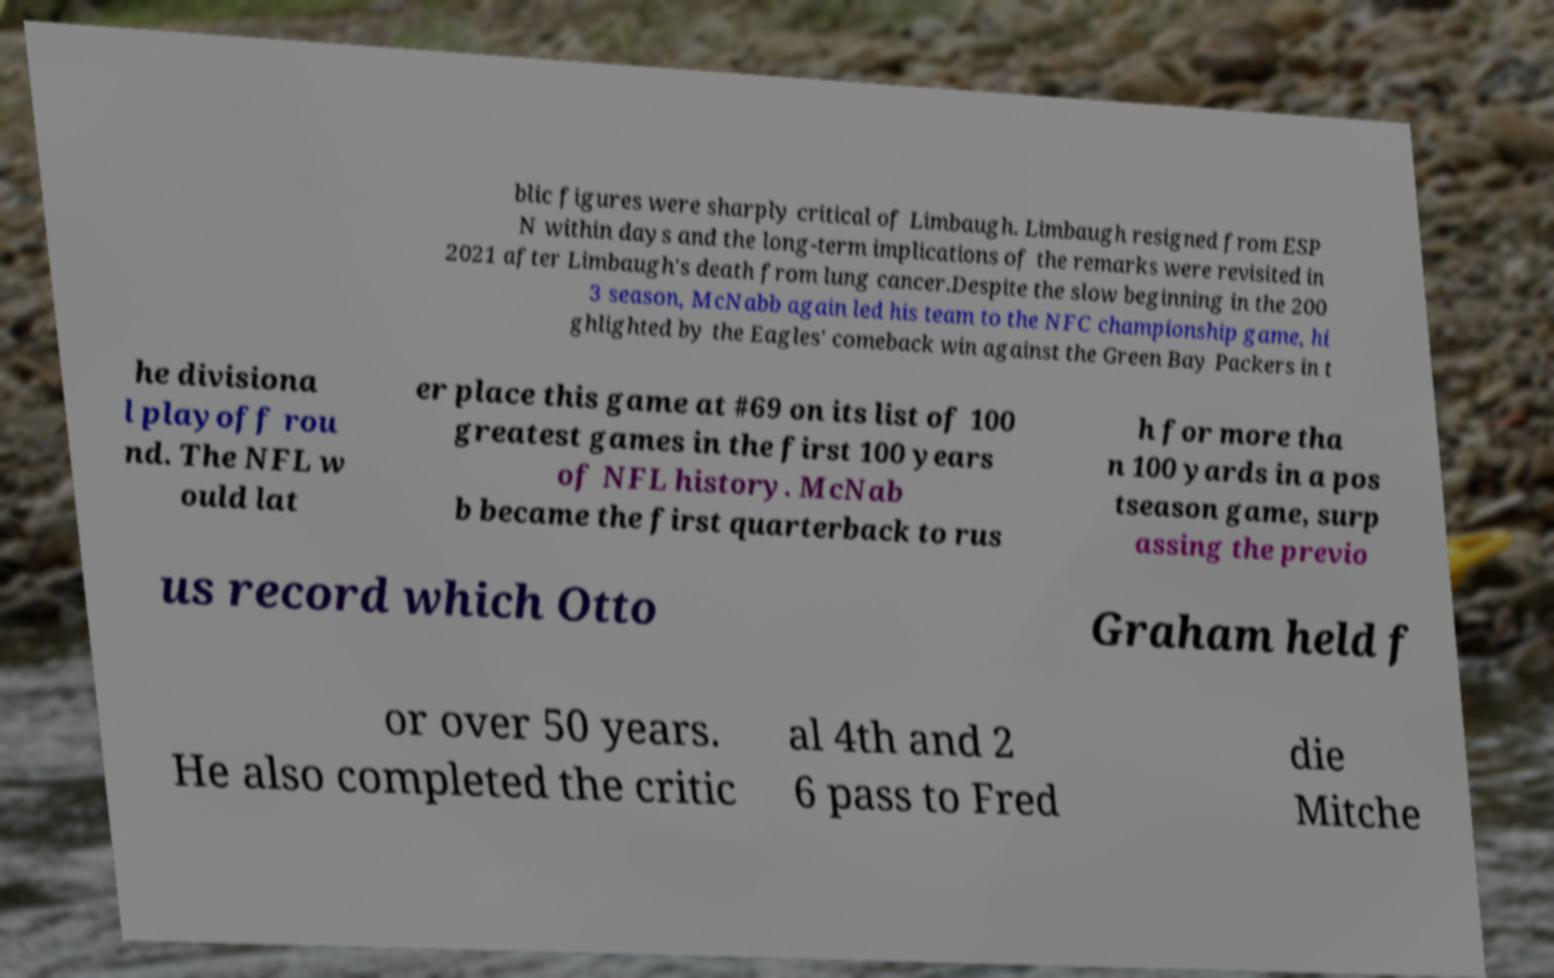Could you extract and type out the text from this image? blic figures were sharply critical of Limbaugh. Limbaugh resigned from ESP N within days and the long-term implications of the remarks were revisited in 2021 after Limbaugh's death from lung cancer.Despite the slow beginning in the 200 3 season, McNabb again led his team to the NFC championship game, hi ghlighted by the Eagles' comeback win against the Green Bay Packers in t he divisiona l playoff rou nd. The NFL w ould lat er place this game at #69 on its list of 100 greatest games in the first 100 years of NFL history. McNab b became the first quarterback to rus h for more tha n 100 yards in a pos tseason game, surp assing the previo us record which Otto Graham held f or over 50 years. He also completed the critic al 4th and 2 6 pass to Fred die Mitche 